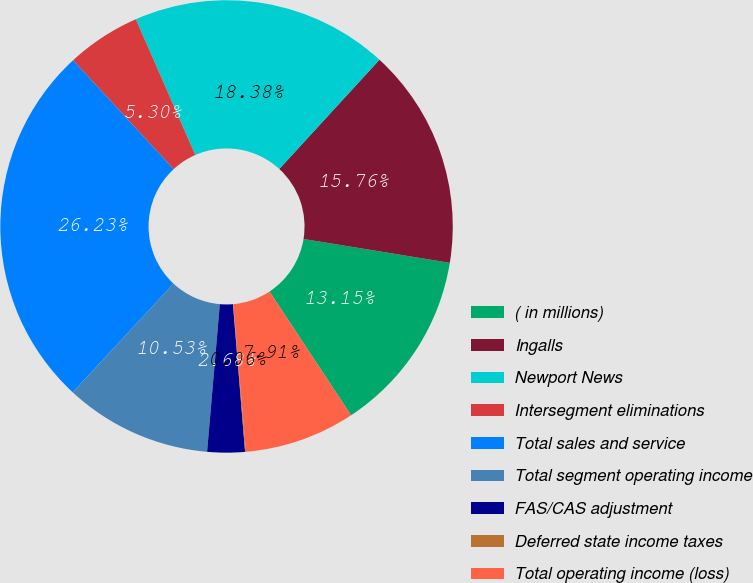<chart> <loc_0><loc_0><loc_500><loc_500><pie_chart><fcel>( in millions)<fcel>Ingalls<fcel>Newport News<fcel>Intersegment eliminations<fcel>Total sales and service<fcel>Total segment operating income<fcel>FAS/CAS adjustment<fcel>Deferred state income taxes<fcel>Total operating income (loss)<nl><fcel>13.15%<fcel>15.76%<fcel>18.38%<fcel>5.3%<fcel>26.23%<fcel>10.53%<fcel>2.68%<fcel>0.06%<fcel>7.91%<nl></chart> 